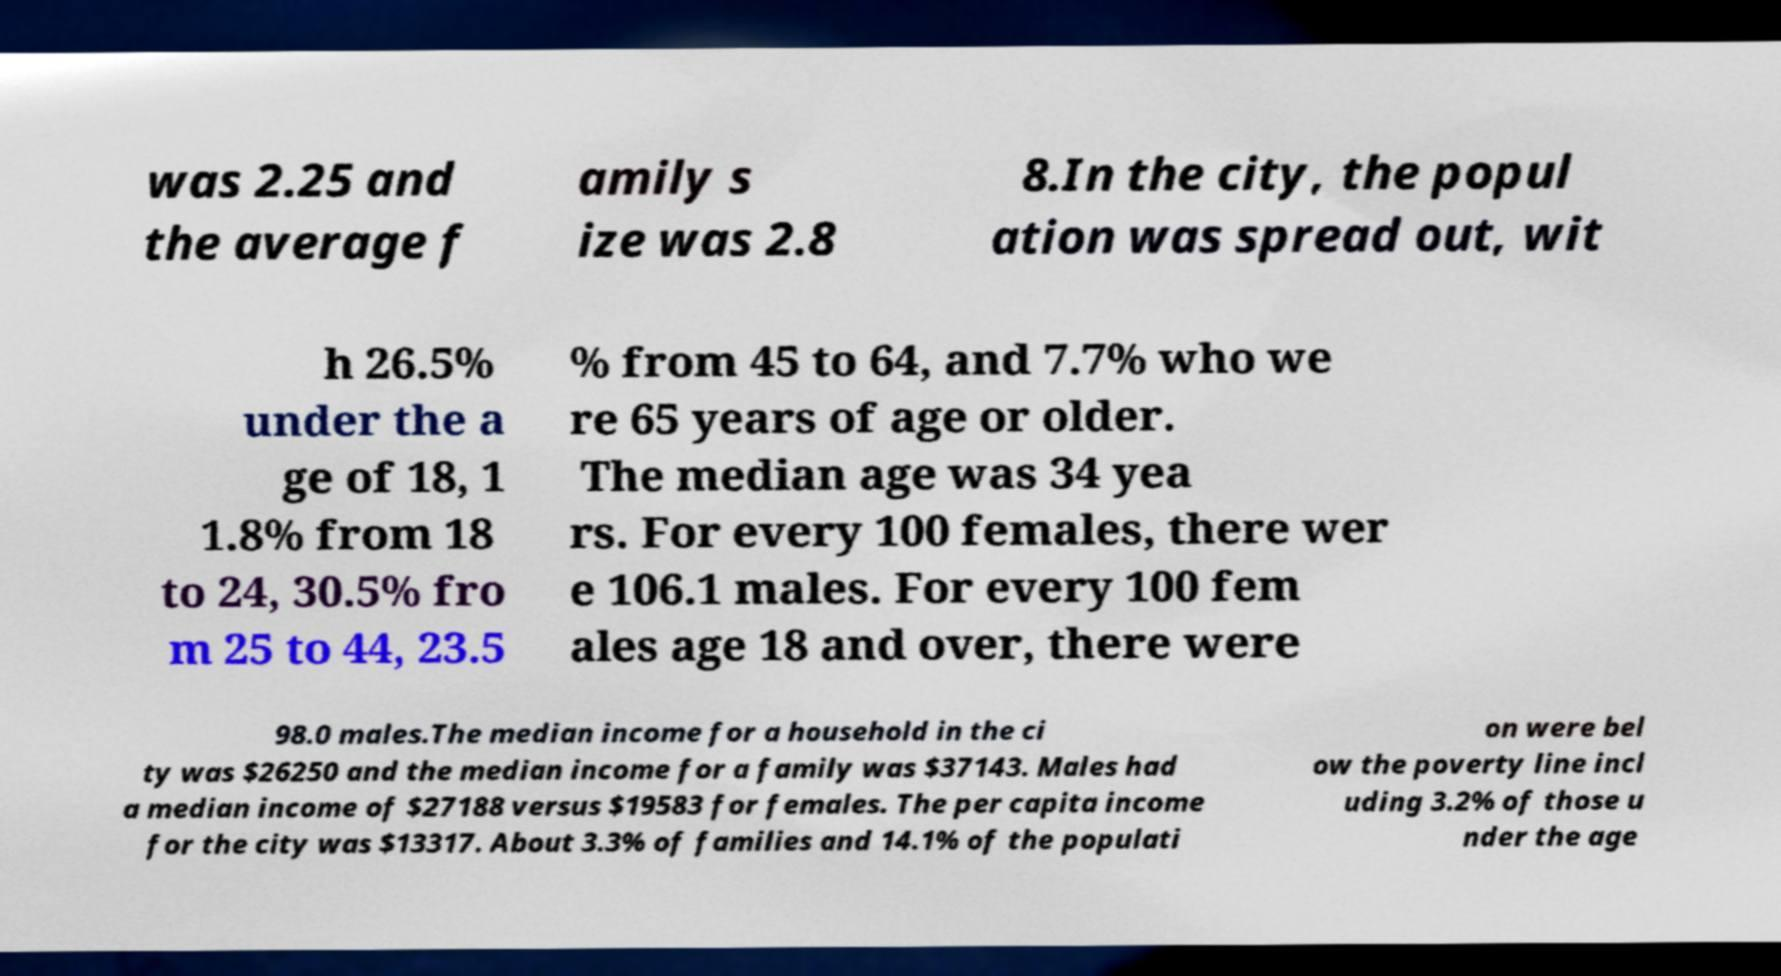Can you accurately transcribe the text from the provided image for me? was 2.25 and the average f amily s ize was 2.8 8.In the city, the popul ation was spread out, wit h 26.5% under the a ge of 18, 1 1.8% from 18 to 24, 30.5% fro m 25 to 44, 23.5 % from 45 to 64, and 7.7% who we re 65 years of age or older. The median age was 34 yea rs. For every 100 females, there wer e 106.1 males. For every 100 fem ales age 18 and over, there were 98.0 males.The median income for a household in the ci ty was $26250 and the median income for a family was $37143. Males had a median income of $27188 versus $19583 for females. The per capita income for the city was $13317. About 3.3% of families and 14.1% of the populati on were bel ow the poverty line incl uding 3.2% of those u nder the age 